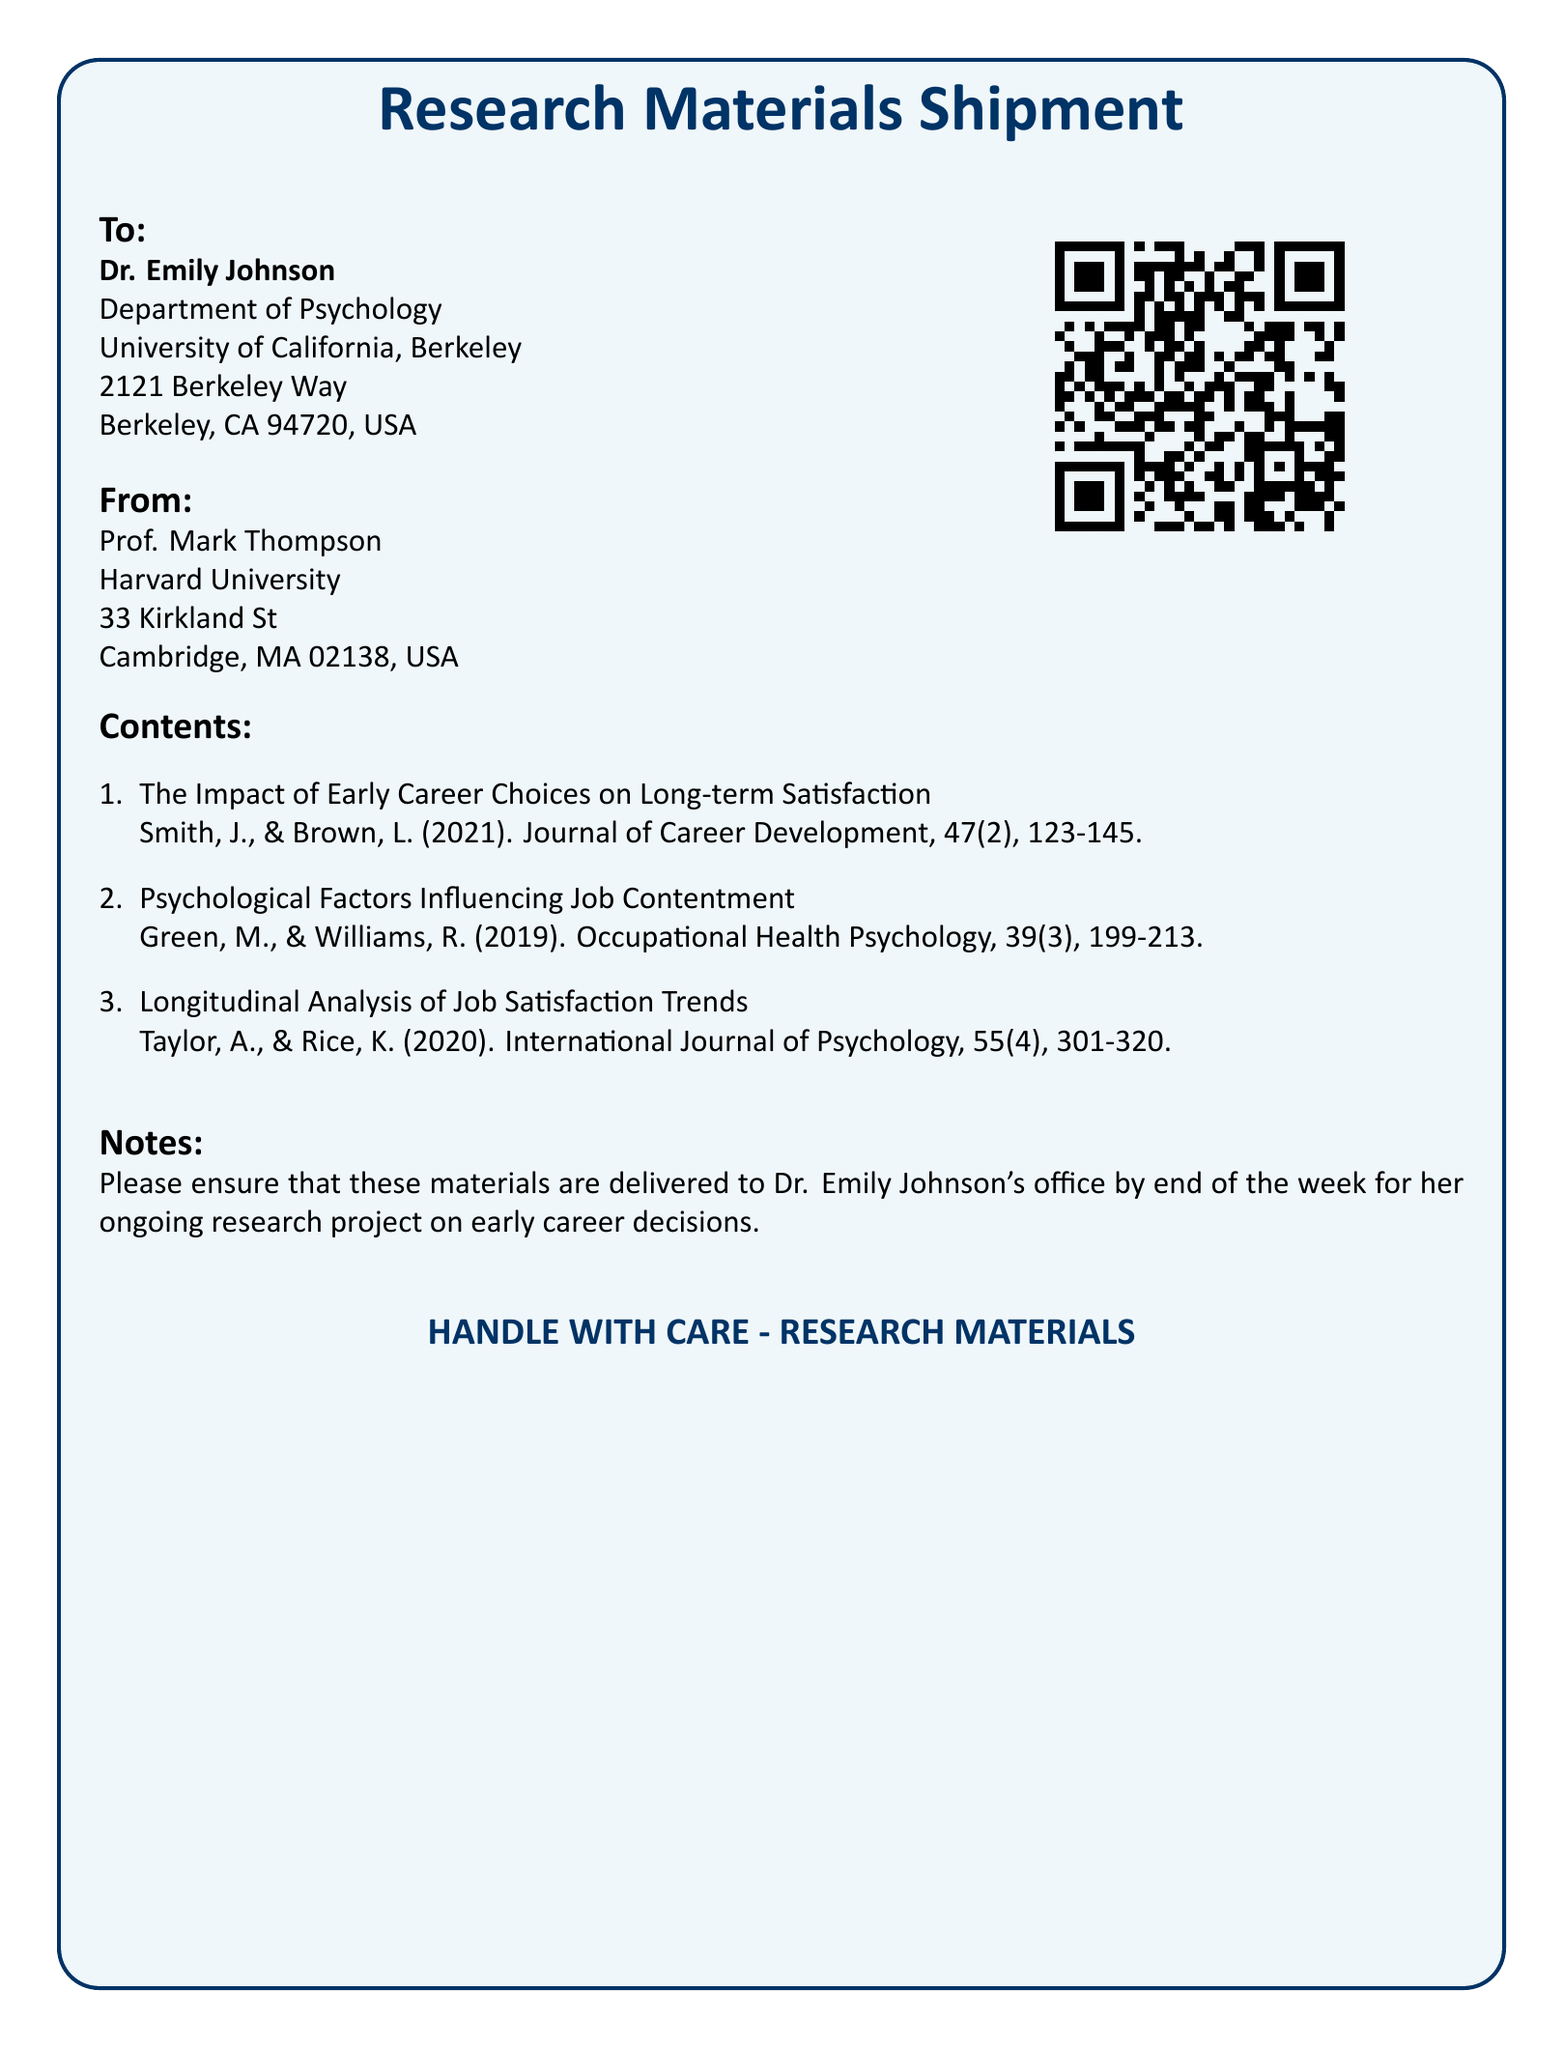What is the recipient's name? The recipient's name is clearly stated in the "To" section of the document, which is Dr. Emily Johnson.
Answer: Dr. Emily Johnson What is the sender's affiliation? The sender's affiliation is listed in the "From" section, indicating he belongs to Harvard University.
Answer: Harvard University What is the specified delivery deadline for the materials? The notes section requests delivery by the end of the week, clearly indicating a time constraint.
Answer: End of the week How many research articles are listed in the contents? The enumeration in the contents section shows there are three articles included.
Answer: 3 What is the primary color theme of the shipment label? The box color used in the document is light blue, which is prominent in the design.
Answer: Light blue What type of materials are being shipped? The label specifies that these are research materials, indicating their purpose.
Answer: Research materials What is the purpose of the QR code included on the label? The QR code is used for additional resources or information related to the shipment, as implied by its presence.
Answer: Accessing information Who is the research aimed at studying? The shipment contains materials related to early career decisions, as indicated in the contents section.
Answer: Early career decisions 